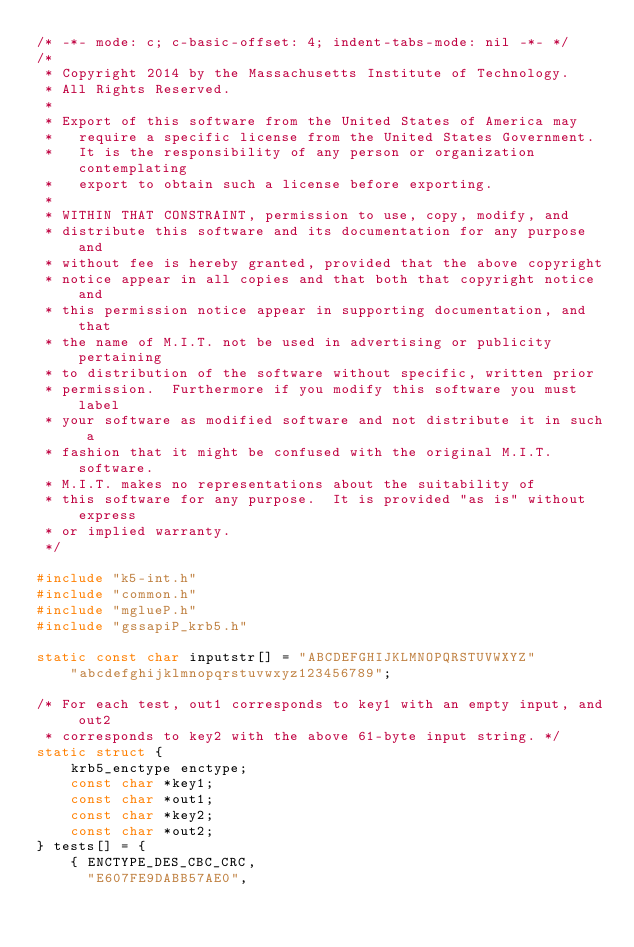Convert code to text. <code><loc_0><loc_0><loc_500><loc_500><_C_>/* -*- mode: c; c-basic-offset: 4; indent-tabs-mode: nil -*- */
/*
 * Copyright 2014 by the Massachusetts Institute of Technology.
 * All Rights Reserved.
 *
 * Export of this software from the United States of America may
 *   require a specific license from the United States Government.
 *   It is the responsibility of any person or organization contemplating
 *   export to obtain such a license before exporting.
 *
 * WITHIN THAT CONSTRAINT, permission to use, copy, modify, and
 * distribute this software and its documentation for any purpose and
 * without fee is hereby granted, provided that the above copyright
 * notice appear in all copies and that both that copyright notice and
 * this permission notice appear in supporting documentation, and that
 * the name of M.I.T. not be used in advertising or publicity pertaining
 * to distribution of the software without specific, written prior
 * permission.  Furthermore if you modify this software you must label
 * your software as modified software and not distribute it in such a
 * fashion that it might be confused with the original M.I.T. software.
 * M.I.T. makes no representations about the suitability of
 * this software for any purpose.  It is provided "as is" without express
 * or implied warranty.
 */

#include "k5-int.h"
#include "common.h"
#include "mglueP.h"
#include "gssapiP_krb5.h"

static const char inputstr[] = "ABCDEFGHIJKLMNOPQRSTUVWXYZ"
    "abcdefghijklmnopqrstuvwxyz123456789";

/* For each test, out1 corresponds to key1 with an empty input, and out2
 * corresponds to key2 with the above 61-byte input string. */
static struct {
    krb5_enctype enctype;
    const char *key1;
    const char *out1;
    const char *key2;
    const char *out2;
} tests[] = {
    { ENCTYPE_DES_CBC_CRC,
      "E607FE9DABB57AE0",</code> 